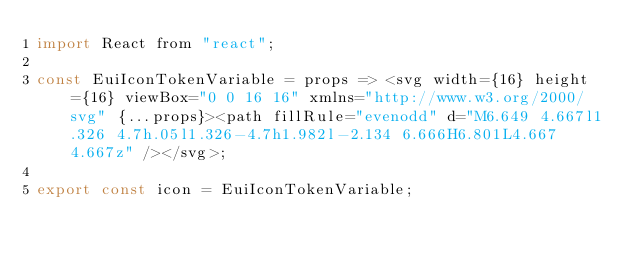Convert code to text. <code><loc_0><loc_0><loc_500><loc_500><_JavaScript_>import React from "react";

const EuiIconTokenVariable = props => <svg width={16} height={16} viewBox="0 0 16 16" xmlns="http://www.w3.org/2000/svg" {...props}><path fillRule="evenodd" d="M6.649 4.667l1.326 4.7h.05l1.326-4.7h1.982l-2.134 6.666H6.801L4.667 4.667z" /></svg>;

export const icon = EuiIconTokenVariable;</code> 